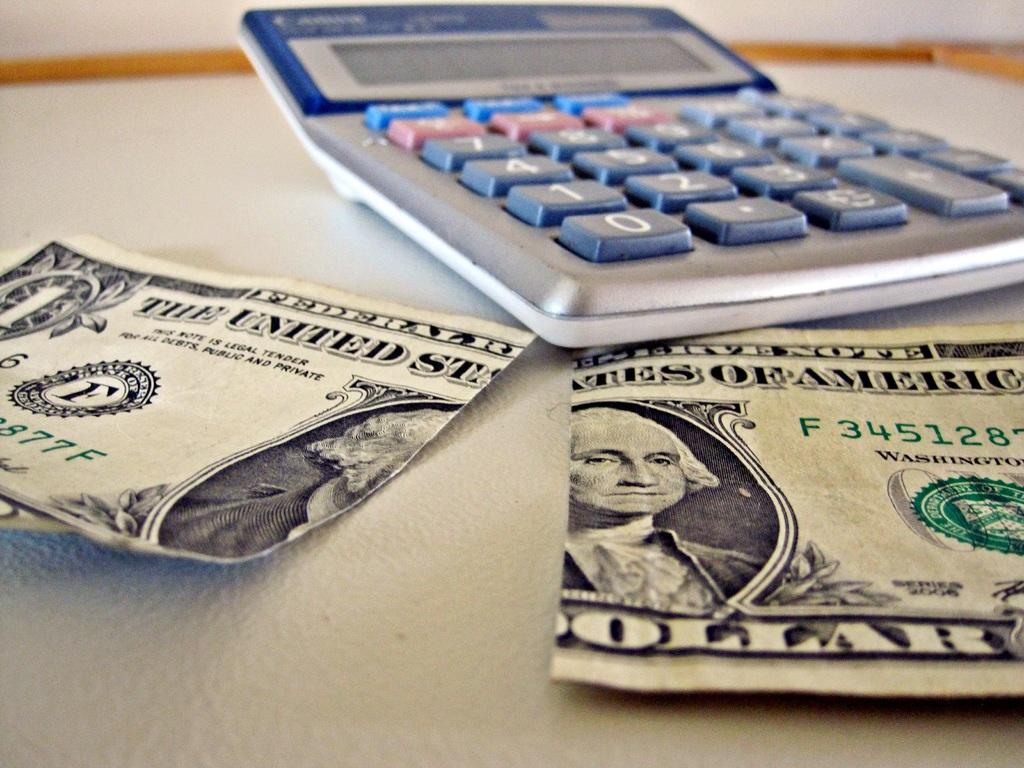<image>
Describe the image concisely. A calculator and ripped Dollar Bill on a table 